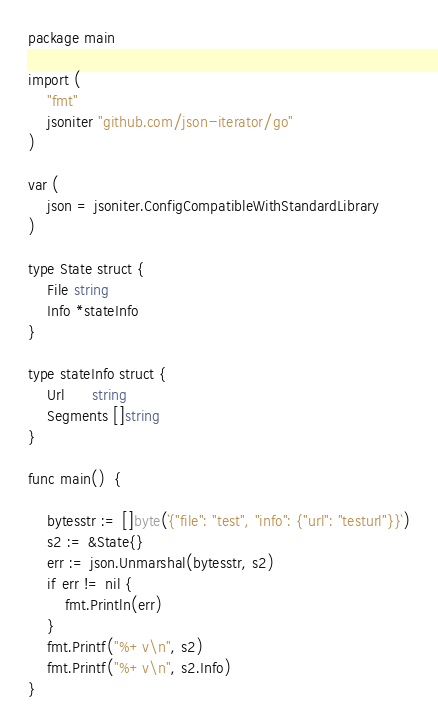Convert code to text. <code><loc_0><loc_0><loc_500><loc_500><_Go_>package main

import (
	"fmt"
	jsoniter "github.com/json-iterator/go"
)

var (
	json = jsoniter.ConfigCompatibleWithStandardLibrary
)

type State struct {
	File string
	Info *stateInfo
}

type stateInfo struct {
	Url      string
	Segments []string
}

func main()  {

	bytesstr := []byte(`{"file": "test", "info": {"url": "testurl"}}`)
	s2 := &State{}
	err := json.Unmarshal(bytesstr, s2)
	if err != nil {
		fmt.Println(err)
	}
	fmt.Printf("%+v\n", s2)
	fmt.Printf("%+v\n", s2.Info)
}

</code> 